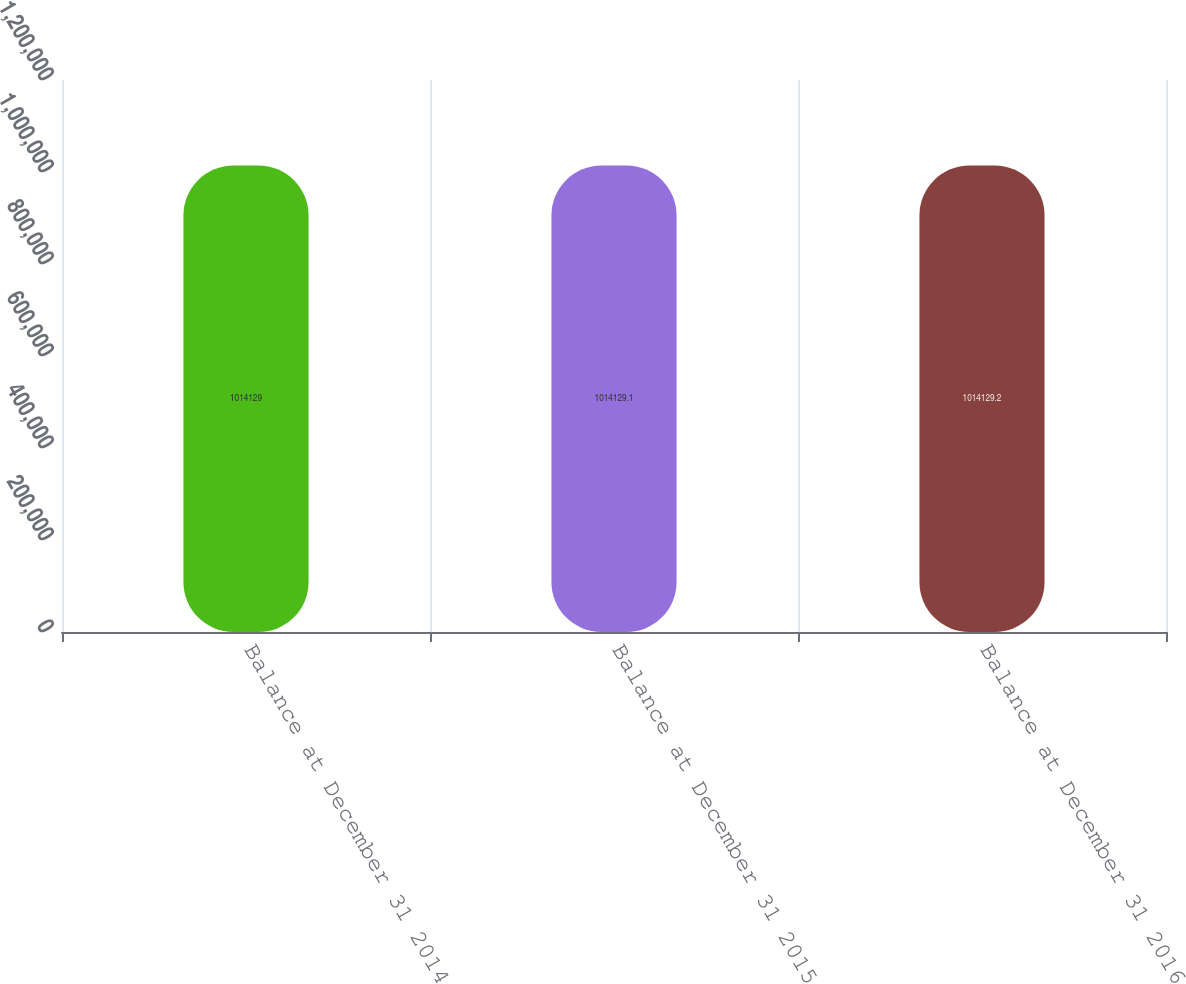Convert chart. <chart><loc_0><loc_0><loc_500><loc_500><bar_chart><fcel>Balance at December 31 2014<fcel>Balance at December 31 2015<fcel>Balance at December 31 2016<nl><fcel>1.01413e+06<fcel>1.01413e+06<fcel>1.01413e+06<nl></chart> 